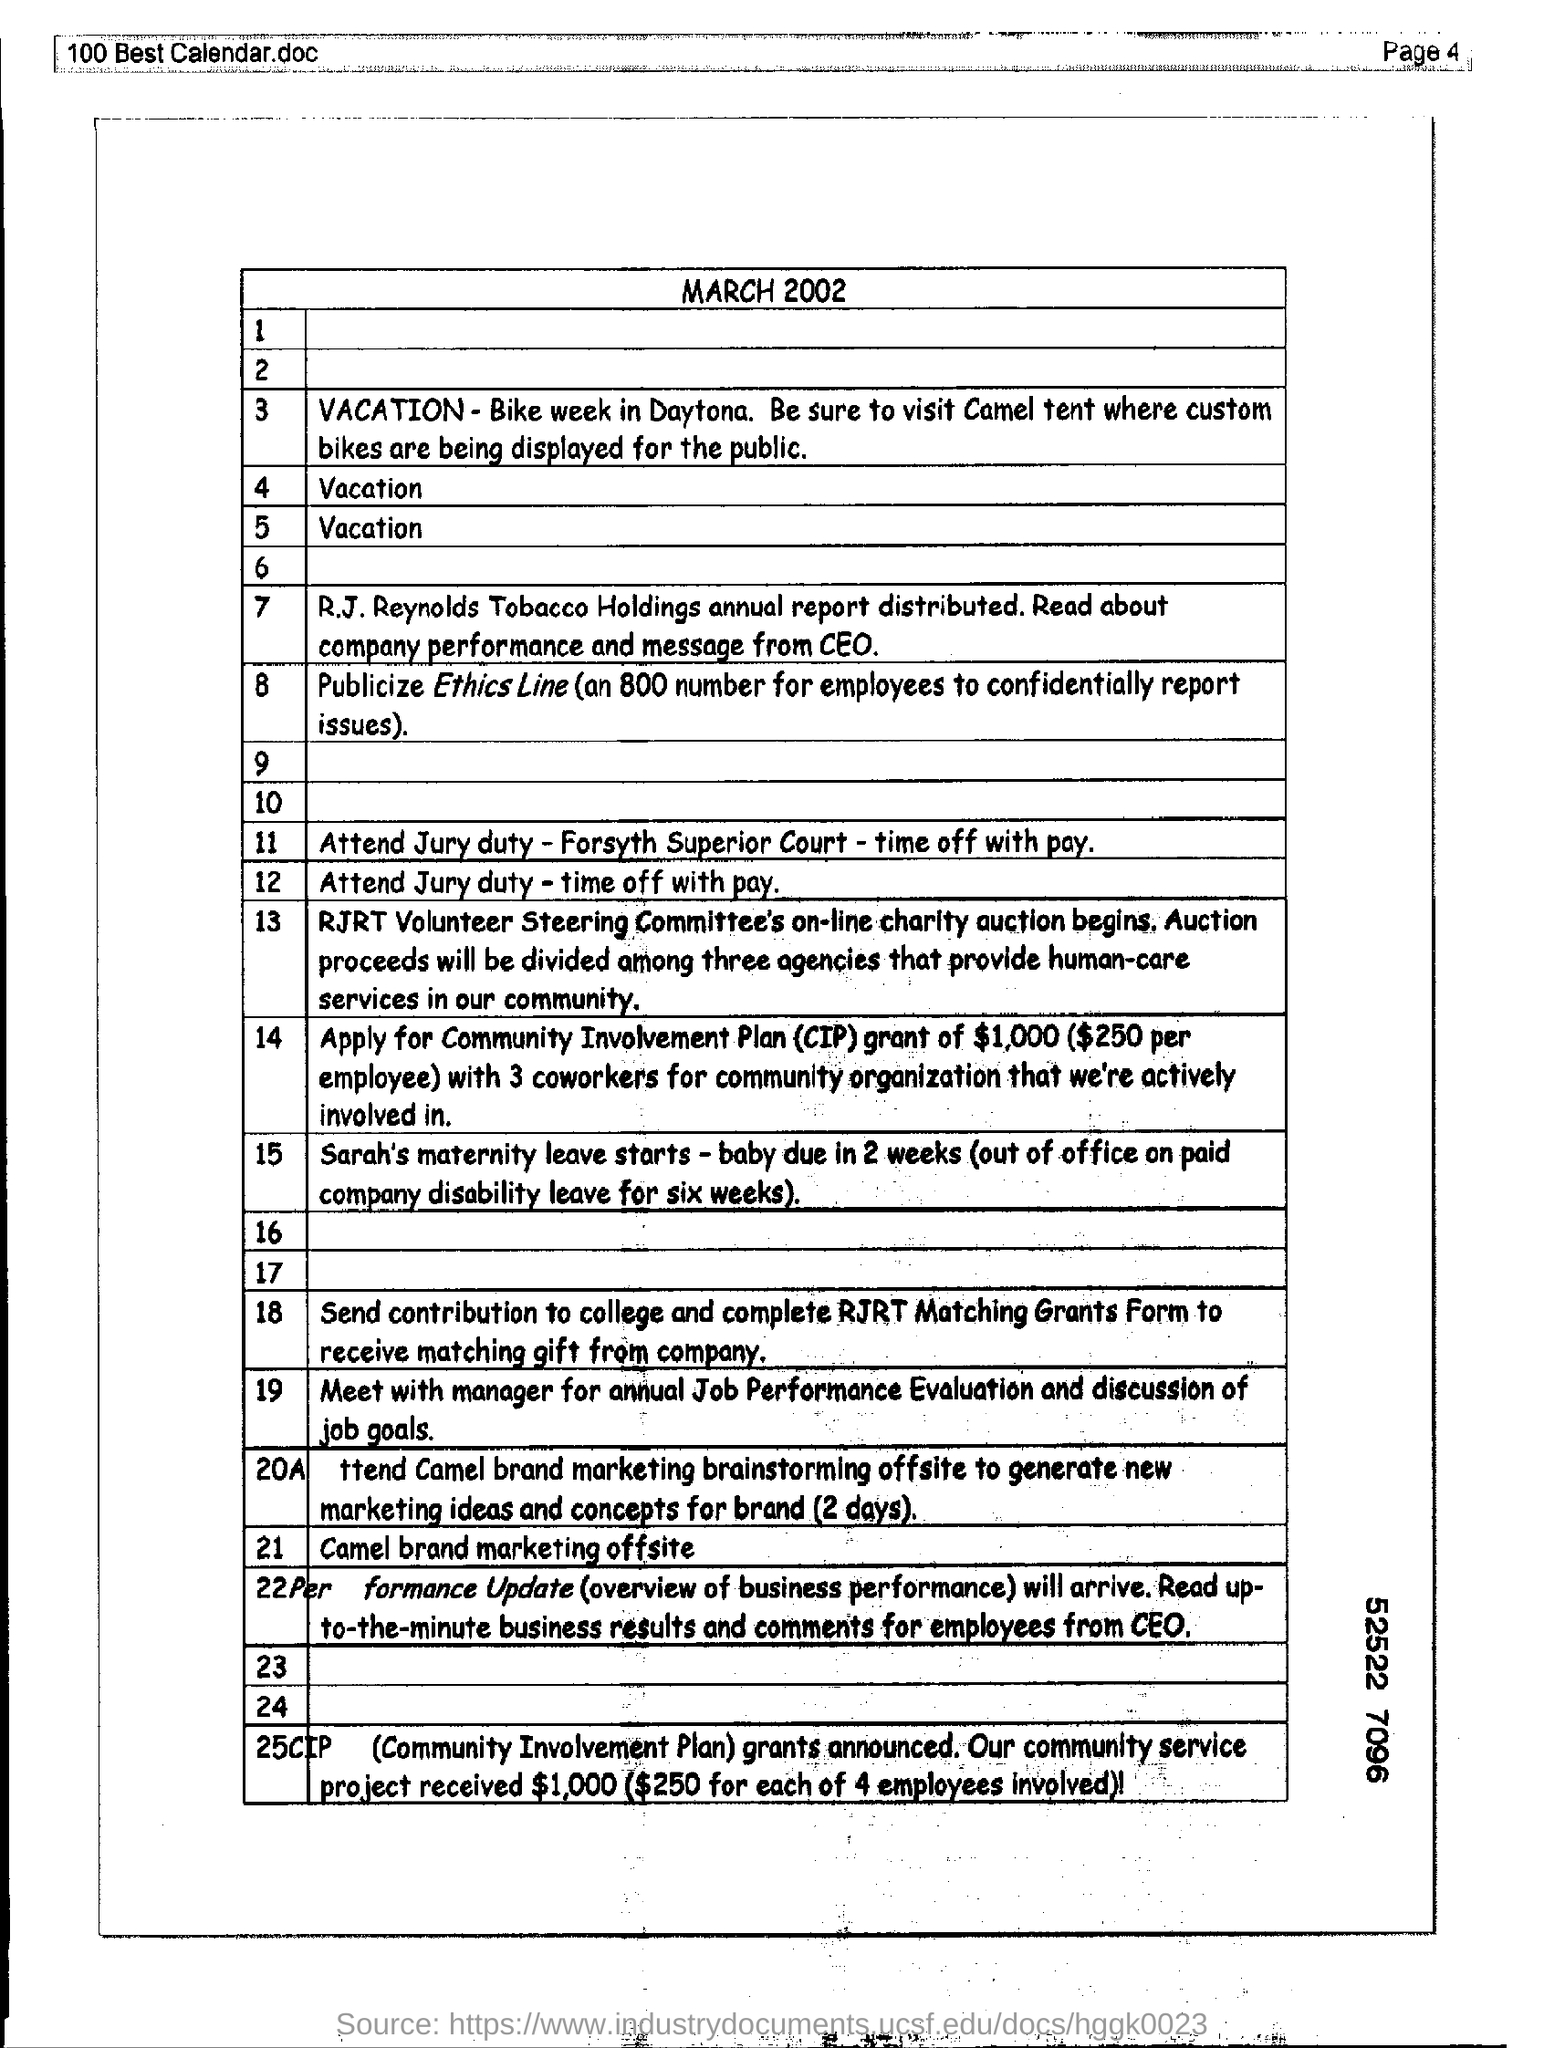Which document name is mentioned in the header of the page?
Your answer should be very brief. 100 best calendar.doc. What is the page number written in the header?
Your response must be concise. Page 4. What is given as document heading?
Provide a succinct answer. MARCH 2002. What is mentioned as 11th activity in the list?
Keep it short and to the point. Attend jury duty - forsyth superior court - time off with pay. How much amount in $ is for "per employee" based on 14th statement?
Your answer should be very brief. 250. About whose maternity leave is stated in 15th statement?
Ensure brevity in your answer.  Sarah's. 